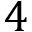<formula> <loc_0><loc_0><loc_500><loc_500>4</formula> 